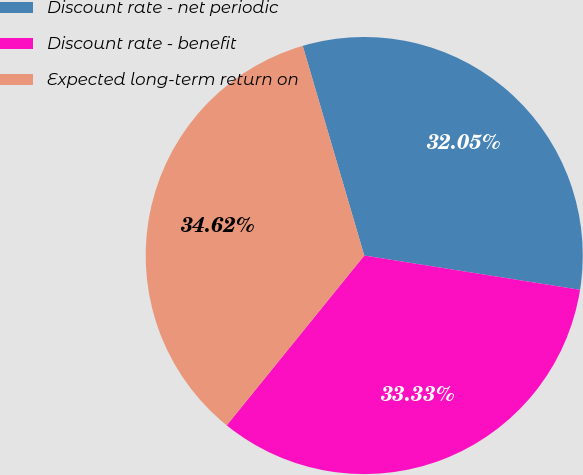Convert chart to OTSL. <chart><loc_0><loc_0><loc_500><loc_500><pie_chart><fcel>Discount rate - net periodic<fcel>Discount rate - benefit<fcel>Expected long-term return on<nl><fcel>32.05%<fcel>33.33%<fcel>34.62%<nl></chart> 